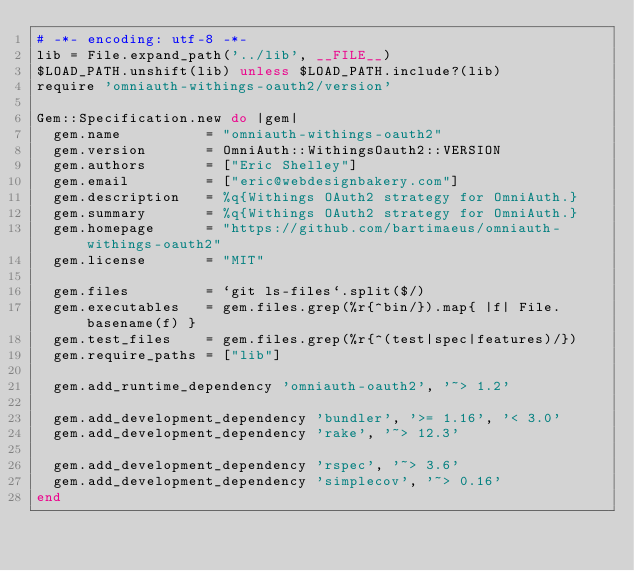<code> <loc_0><loc_0><loc_500><loc_500><_Ruby_># -*- encoding: utf-8 -*-
lib = File.expand_path('../lib', __FILE__)
$LOAD_PATH.unshift(lib) unless $LOAD_PATH.include?(lib)
require 'omniauth-withings-oauth2/version'

Gem::Specification.new do |gem|
  gem.name          = "omniauth-withings-oauth2"
  gem.version       = OmniAuth::WithingsOauth2::VERSION
  gem.authors       = ["Eric Shelley"]
  gem.email         = ["eric@webdesignbakery.com"]
  gem.description   = %q{Withings OAuth2 strategy for OmniAuth.}
  gem.summary       = %q{Withings OAuth2 strategy for OmniAuth.}
  gem.homepage      = "https://github.com/bartimaeus/omniauth-withings-oauth2"
  gem.license       = "MIT"

  gem.files         = `git ls-files`.split($/)
  gem.executables   = gem.files.grep(%r{^bin/}).map{ |f| File.basename(f) }
  gem.test_files    = gem.files.grep(%r{^(test|spec|features)/})
  gem.require_paths = ["lib"]

  gem.add_runtime_dependency 'omniauth-oauth2', '~> 1.2'

  gem.add_development_dependency 'bundler', '>= 1.16', '< 3.0'
  gem.add_development_dependency 'rake', '~> 12.3'

  gem.add_development_dependency 'rspec', '~> 3.6'
  gem.add_development_dependency 'simplecov', '~> 0.16'
end
</code> 